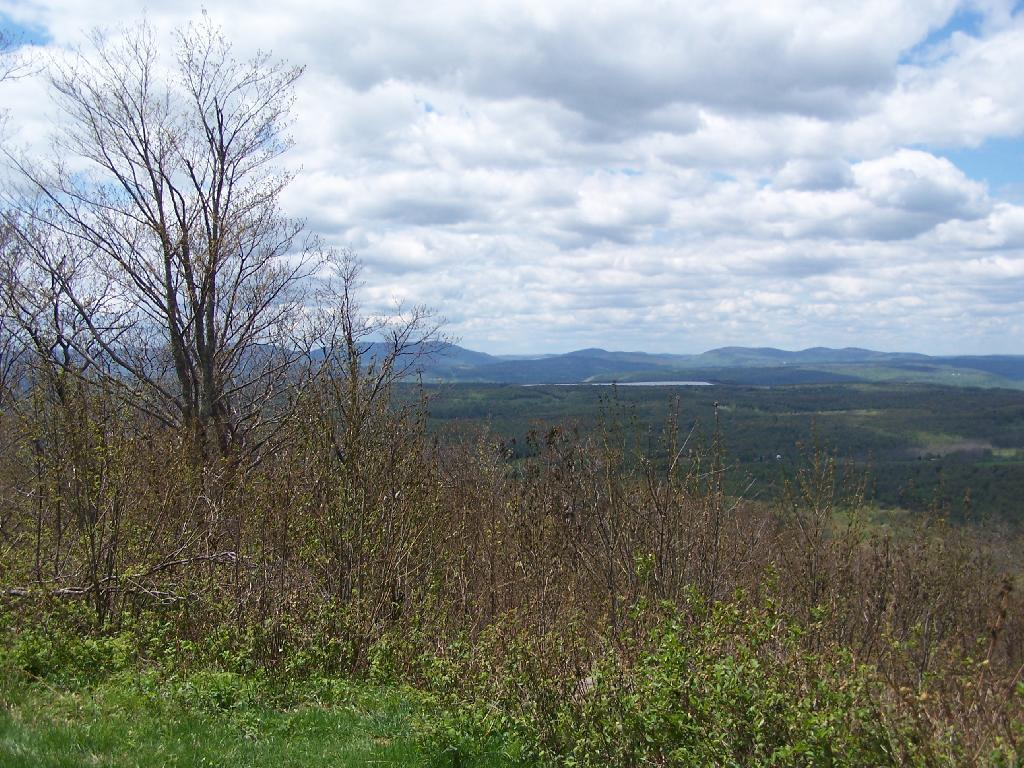What type of vegetation can be seen in the image? There is grass, plants, and trees visible in the image. What natural feature can be seen in the image? There is water visible in the image. What geographical feature is present in the image? There are mountains in the image. What part of the natural environment is visible in the image? The sky is visible in the image. What time of day might the image have been taken? The image was likely taken during the day, as the sky is visible. What book is the person reading in the image? There is no person or book present in the image. What size are the mountains in the image? The size of the mountains cannot be determined from the image alone, as there is no reference for scale. 